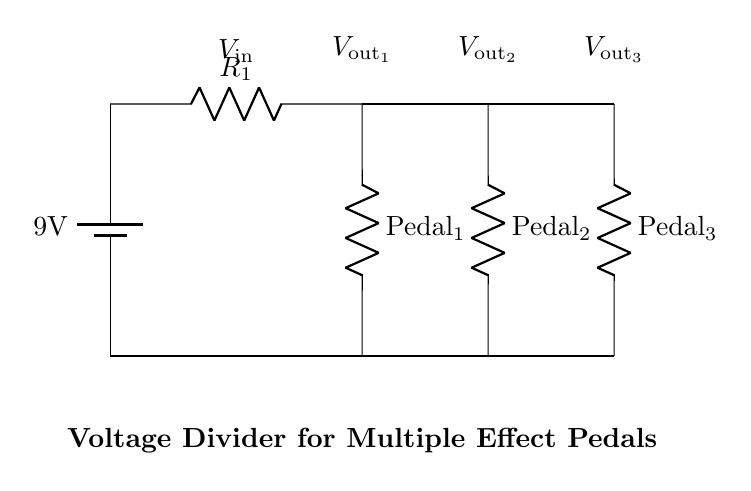What is the input voltage of the circuit? The input voltage is labeled as 9V, connected to the power supply.
Answer: 9V What are the effects pedals powered by? The effect pedals are powered by the output from the voltage divider created by resistor R1 and the respective pedal resistors.
Answer: R1 How many effect pedals are present in the circuit? There are three effect pedals shown in the circuit diagram.
Answer: Three What do you call the component connected to the power supply? The component connected to the power supply is a battery, providing the input voltage.
Answer: Battery What is the purpose of the resistors connected to the pedals? The resistors connected to the pedals are used to limit the voltage and current supplied to each pedal, ensuring they operate properly without being overloaded.
Answer: Limit voltage/current What is the relationship between the output voltages? The output voltages are obtained through a voltage divider, meaning each pedal gets a fraction of the input voltage based on its resistance value relative to the total resistance.
Answer: Voltage divider What could happen if one pedal is turned off or disconnected? Disconnecting one pedal would change the total resistance in the circuit, potentially altering the output voltages to the other pedals, which may cause performance issues.
Answer: Altered outputs 